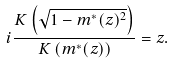<formula> <loc_0><loc_0><loc_500><loc_500>i \frac { K \left ( \sqrt { 1 - m ^ { * } ( z ) ^ { 2 } } \right ) } { K \left ( m ^ { * } ( z ) \right ) } = z .</formula> 